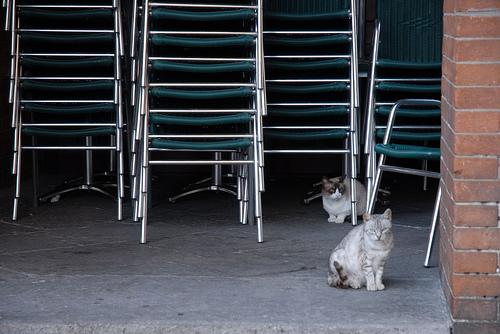If a few more of these animals appear here what would they be called? Please explain your reasoning. clowder. There would be chowder. 